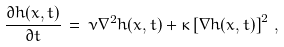<formula> <loc_0><loc_0><loc_500><loc_500>\frac { \partial { h } ( x , t ) } { \partial t } \, = \, \nu { \nabla } ^ { 2 } { h } ( x , t ) + \kappa \left [ \nabla { h } ( x , t ) \right ] ^ { 2 } \, ,</formula> 